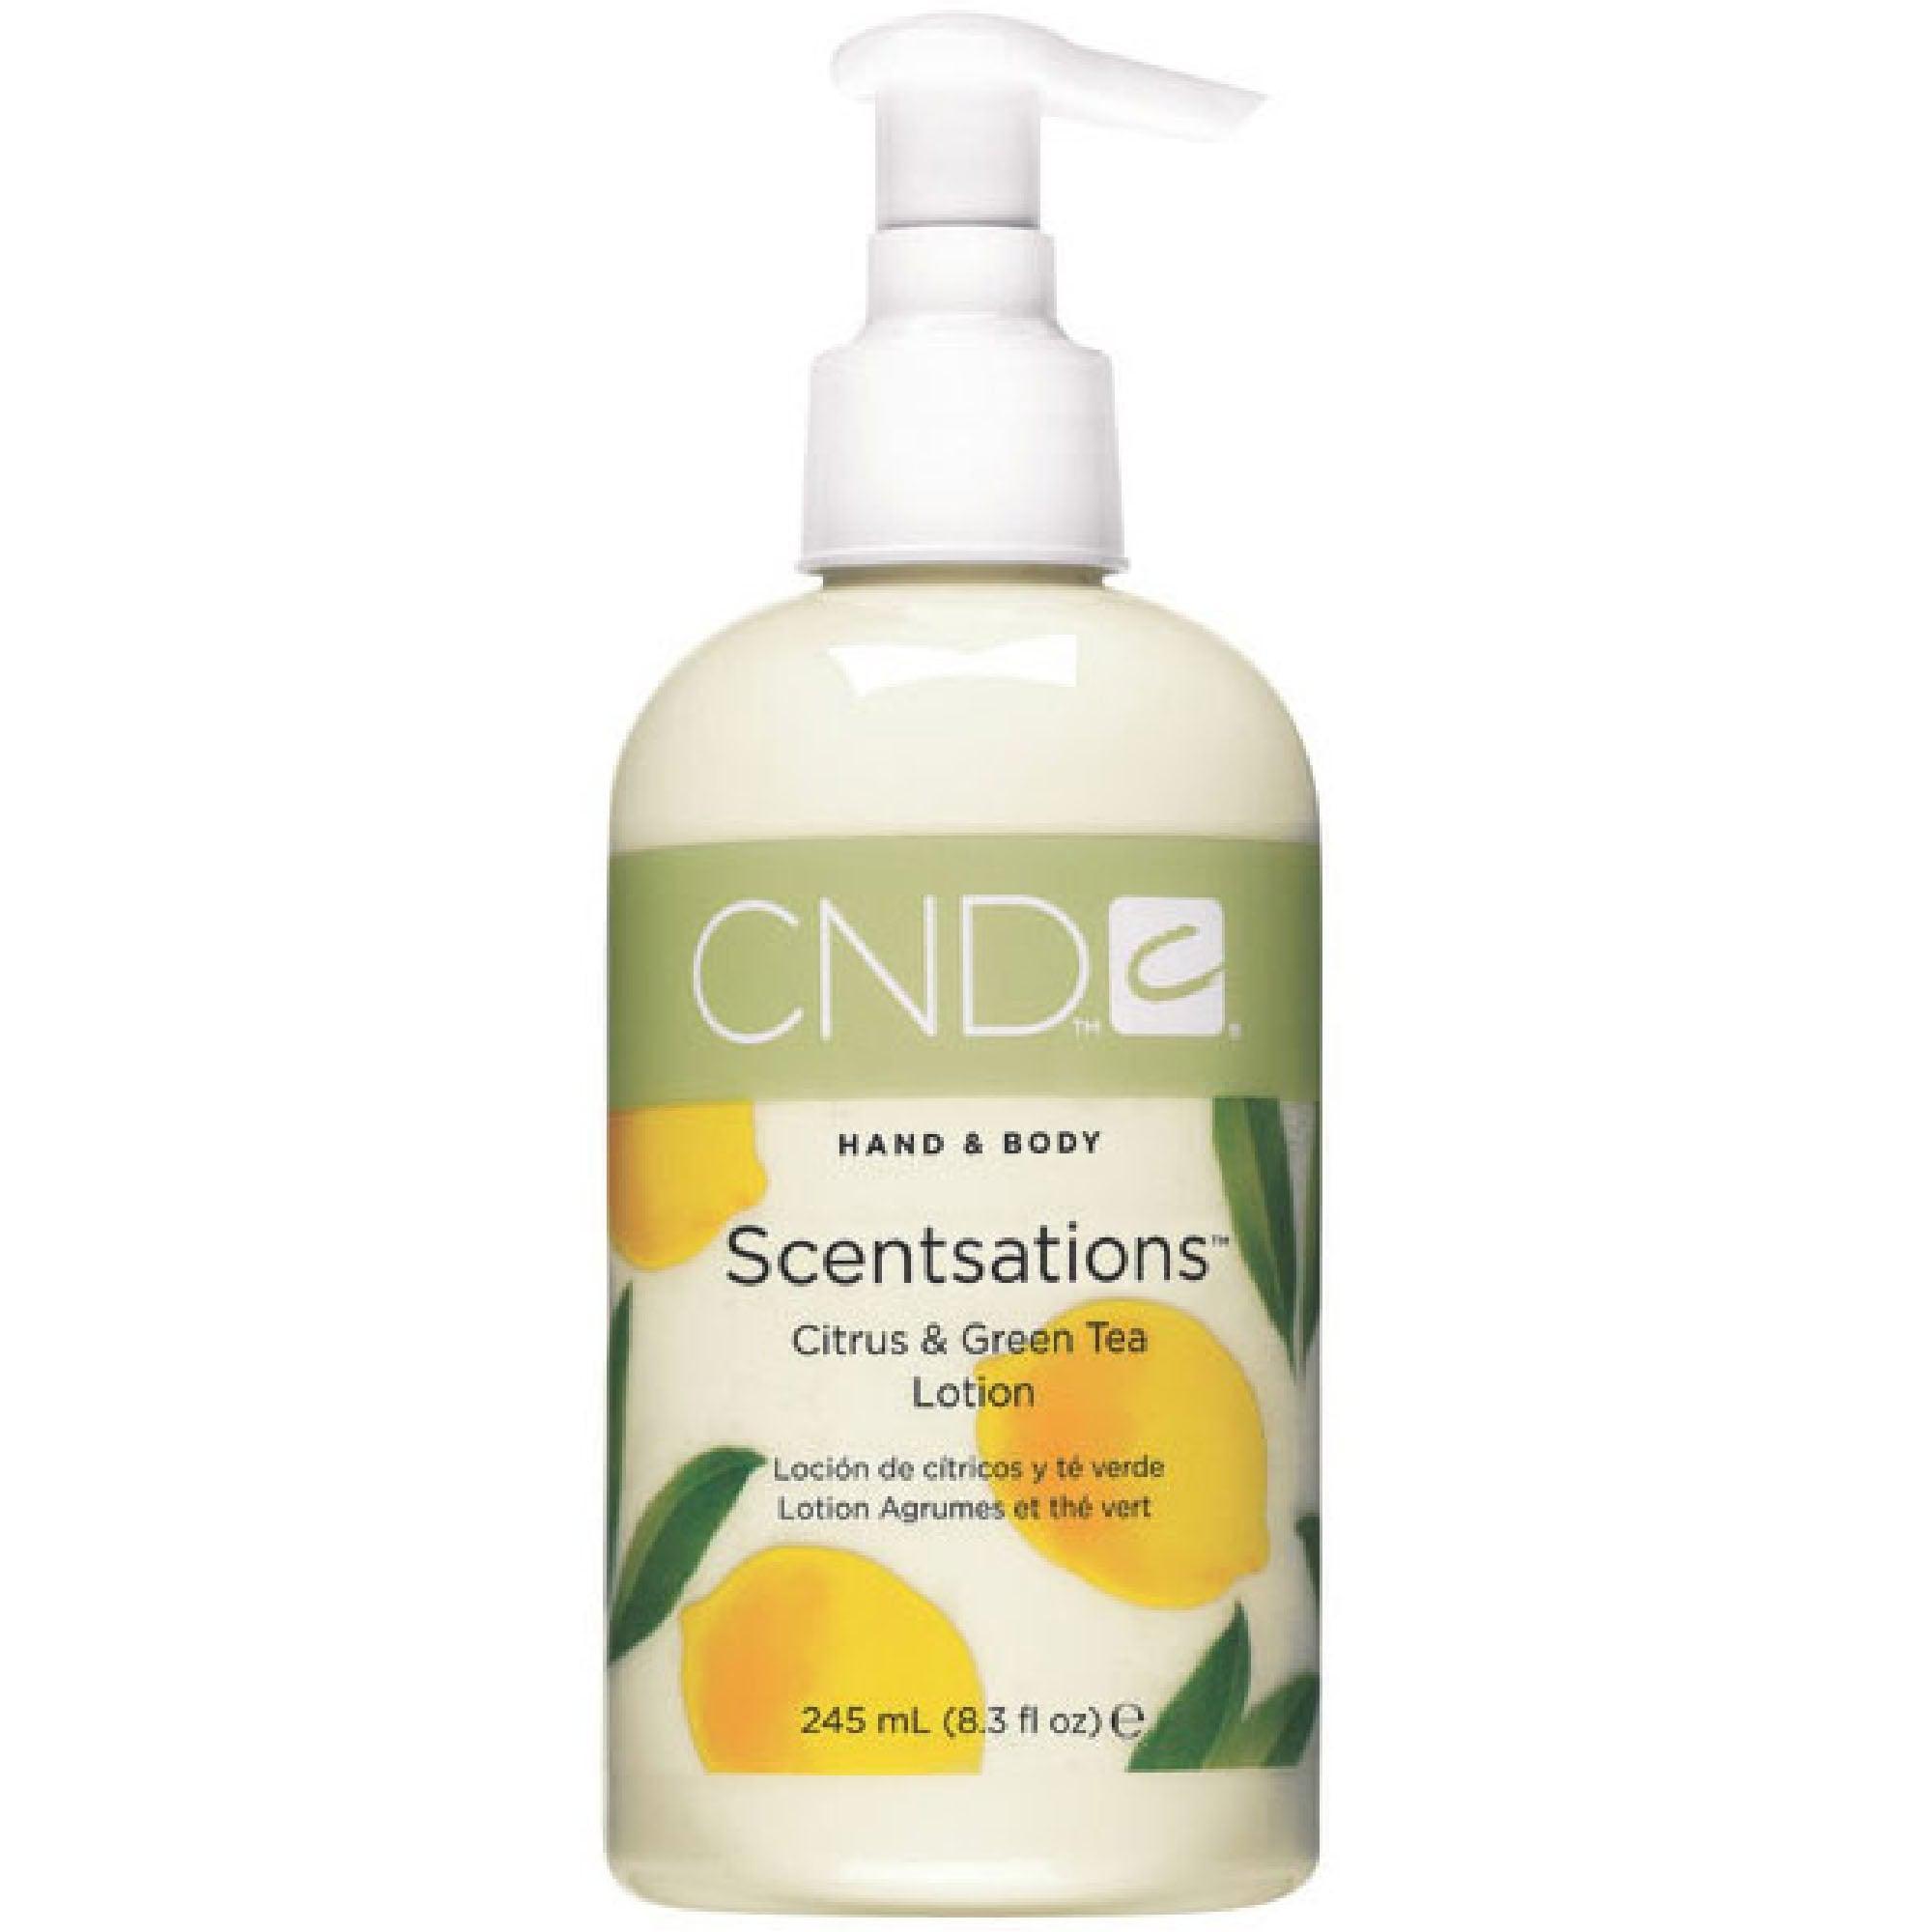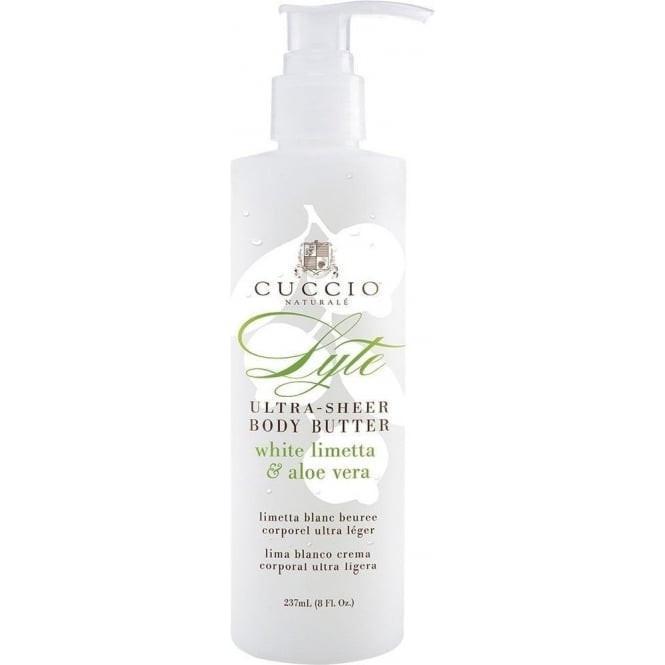The first image is the image on the left, the second image is the image on the right. Evaluate the accuracy of this statement regarding the images: "One bottle has yellow lemons on it.". Is it true? Answer yes or no. Yes. 